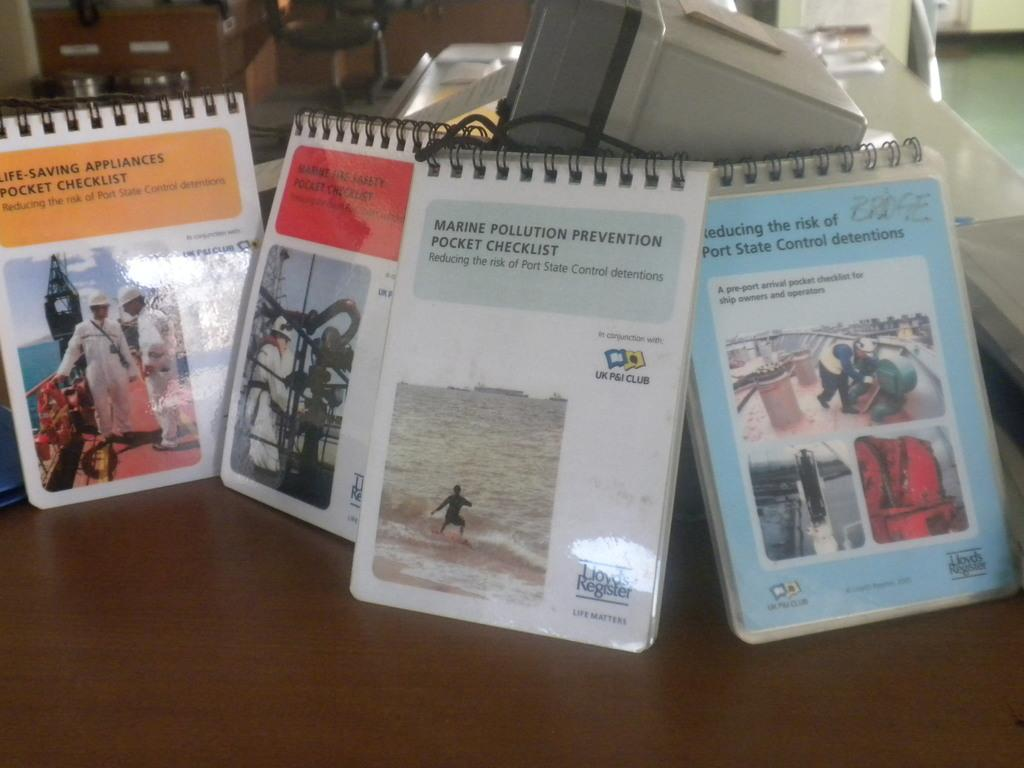What items can be seen on the table in the image? There are notepads and other objects on the table in the image. Can you describe the objects on the table? Unfortunately, the provided facts do not specify the nature of the objects on the table. What can be seen in the background of the image? There is a chair in the background of the image. Where is the toothbrush located in the image? There is no toothbrush present in the image. Is the bulb turned on in the image? There is no bulb present in the image, so it cannot be determined if it is turned on or off. 